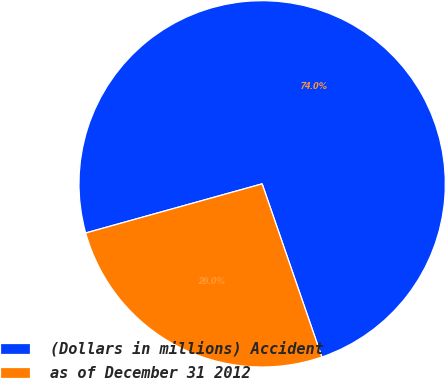Convert chart. <chart><loc_0><loc_0><loc_500><loc_500><pie_chart><fcel>(Dollars in millions) Accident<fcel>as of December 31 2012<nl><fcel>74.04%<fcel>25.96%<nl></chart> 